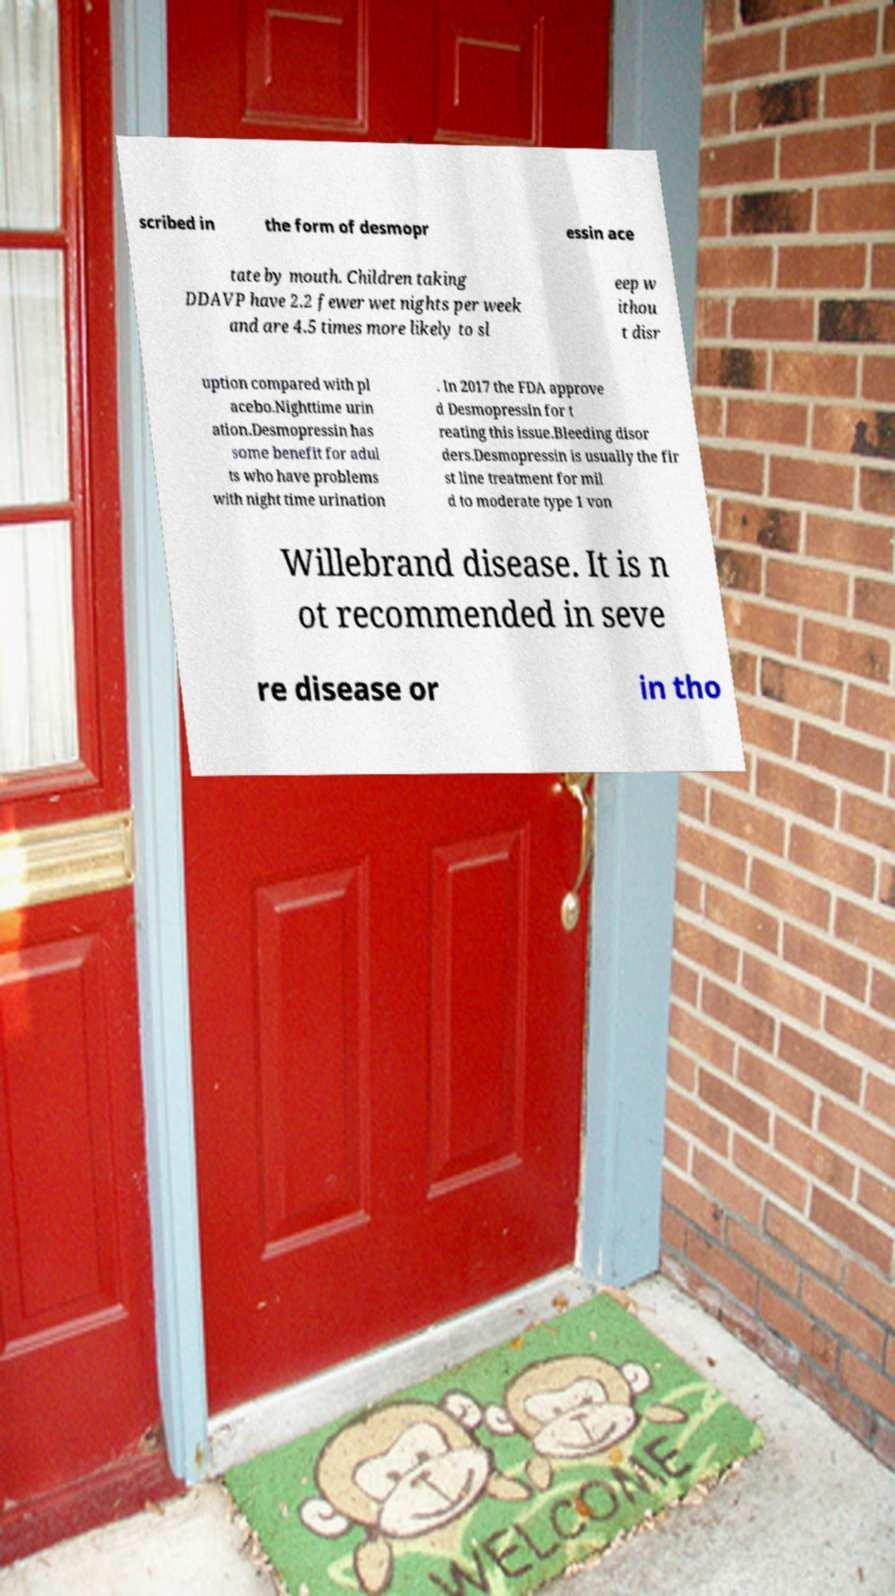Could you extract and type out the text from this image? scribed in the form of desmopr essin ace tate by mouth. Children taking DDAVP have 2.2 fewer wet nights per week and are 4.5 times more likely to sl eep w ithou t disr uption compared with pl acebo.Nighttime urin ation.Desmopressin has some benefit for adul ts who have problems with night time urination . In 2017 the FDA approve d Desmopressin for t reating this issue.Bleeding disor ders.Desmopressin is usually the fir st line treatment for mil d to moderate type 1 von Willebrand disease. It is n ot recommended in seve re disease or in tho 